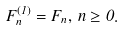<formula> <loc_0><loc_0><loc_500><loc_500>F ^ { ( 1 ) } _ { n } = F _ { n } , \, n \geq 0 .</formula> 